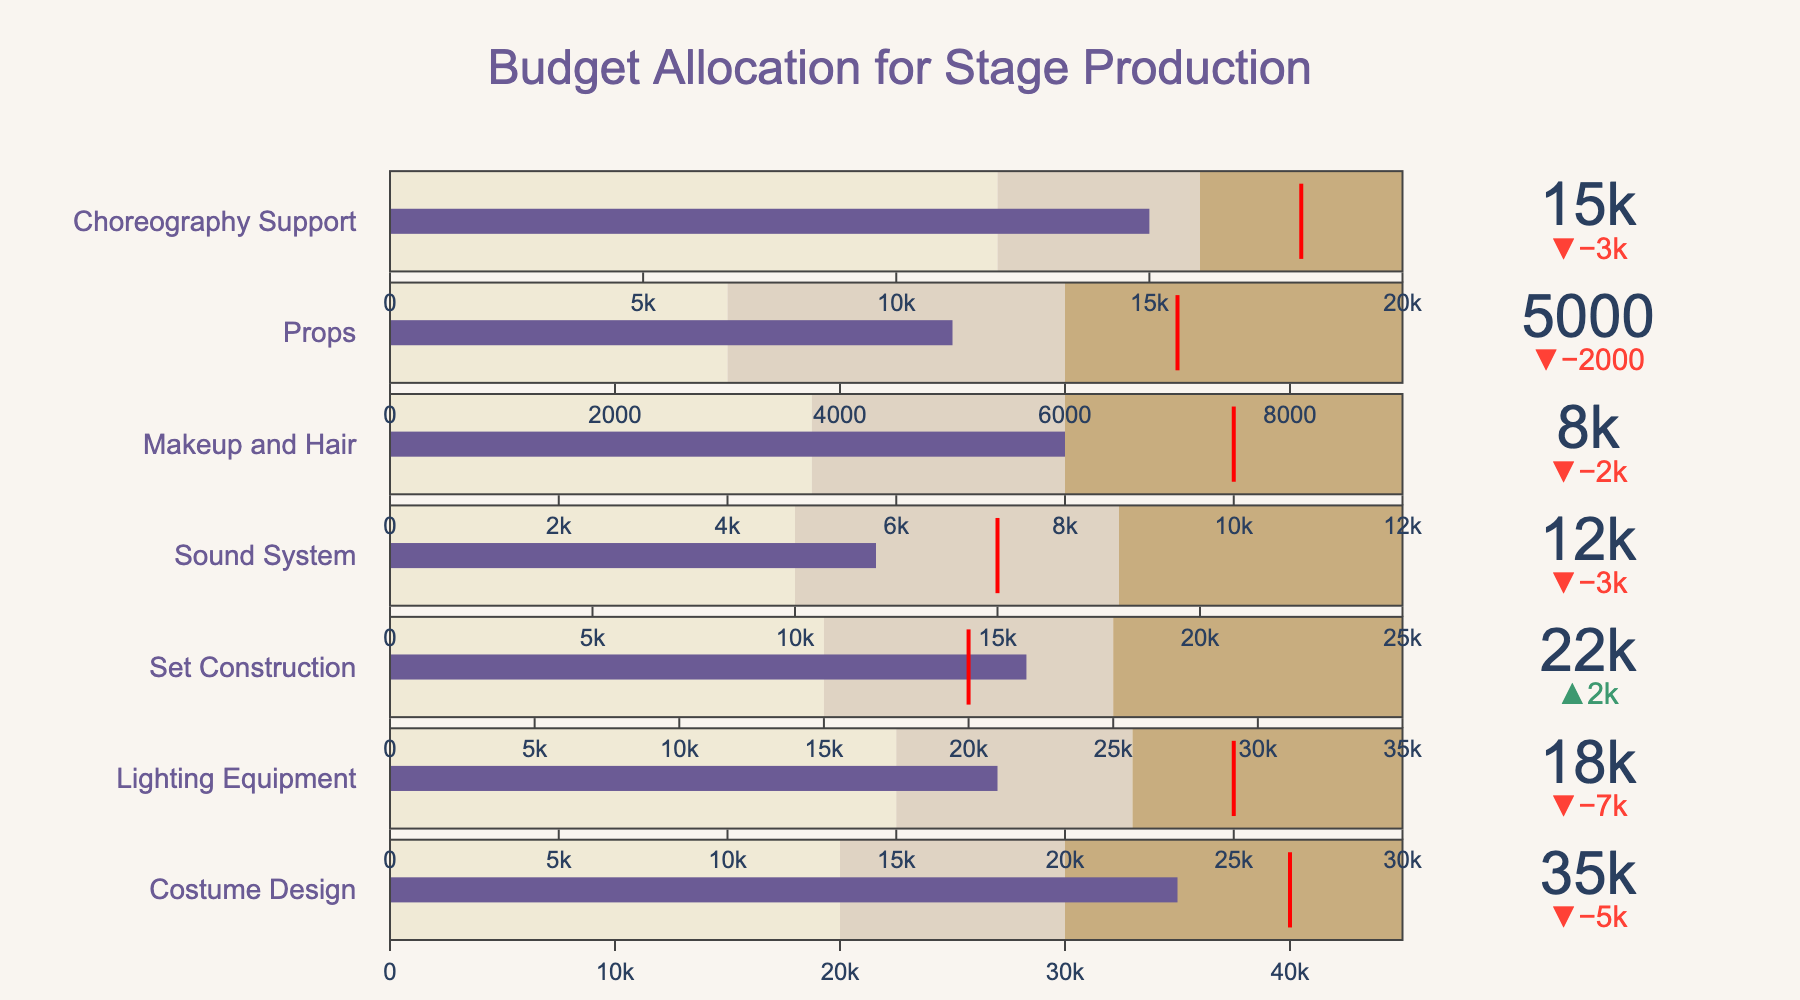What's the title of the figure? The title is typically located at the top of the figure. In this case, it reads "Budget Allocation for Stage Production."
Answer: Budget Allocation for Stage Production How many categories of budget allocation are shown? Each row represents a different category, and counting them yields seven categories.
Answer: Seven Which category has the highest actual budget allocation? By comparing the actual budget values, Costume Design has the highest at 35,000.
Answer: Costume Design Which category exceeded its target budget? By looking at the delta indicators and comparing actual to target values, Set Construction is the category that exceeded its target.
Answer: Set Construction What's the actual budget allocation for Props? The actual budget allocation for Props is explicitly shown as 5,000 in the respective row.
Answer: 5,000 Compare the target budget of Lighting Equipment to that of Choreography Support. Which one has a higher target budget? The target budget for Lighting Equipment is 25,000, and for Choreography Support, it is 18,000. Therefore, Lighting Equipment has a higher target budget.
Answer: Lighting Equipment What is the difference between the actual and target budget allocations for Sound System? The actual budget for Sound System is 12,000, and the target is 15,000. The difference is 15,000 - 12,000.
Answer: 3,000 In which categories is the actual budget within the "Range 2" boundary? For both Makeup and Hair, and Choreography Support, the actual budget allocations (8,000 and 15,000 respectively) fall within their respective "Range 2" boundaries (8,000-12,000 and 12,000-16,000).
Answer: Makeup and Hair, Choreography Support How much less is the actual budget for Lighting Equipment compared to its target budget? The actual budget for Lighting Equipment is 18,000, and the target is 25,000. The difference is 25,000 - 18,000.
Answer: 7,000 